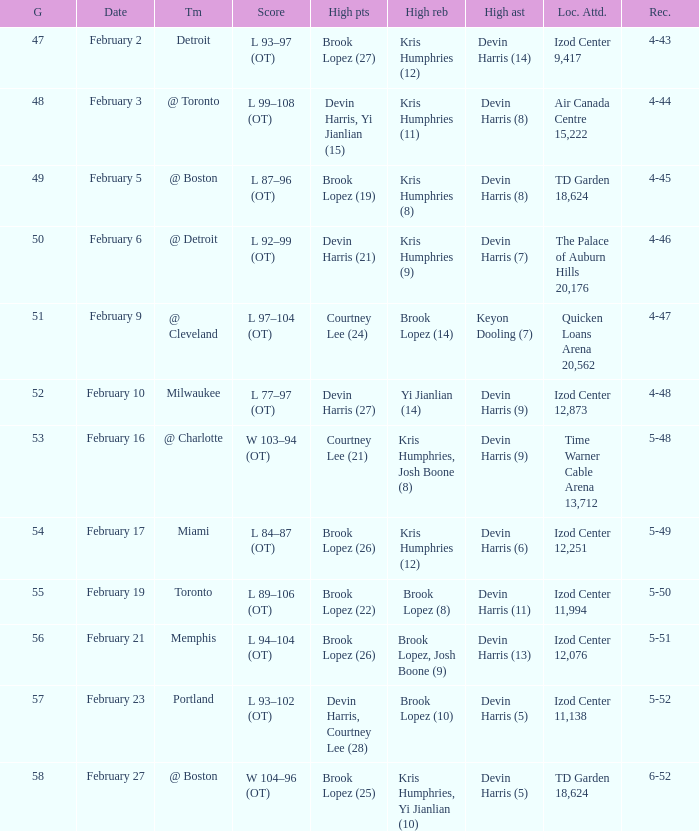What team was the game on February 27 played against? @ Boston. 